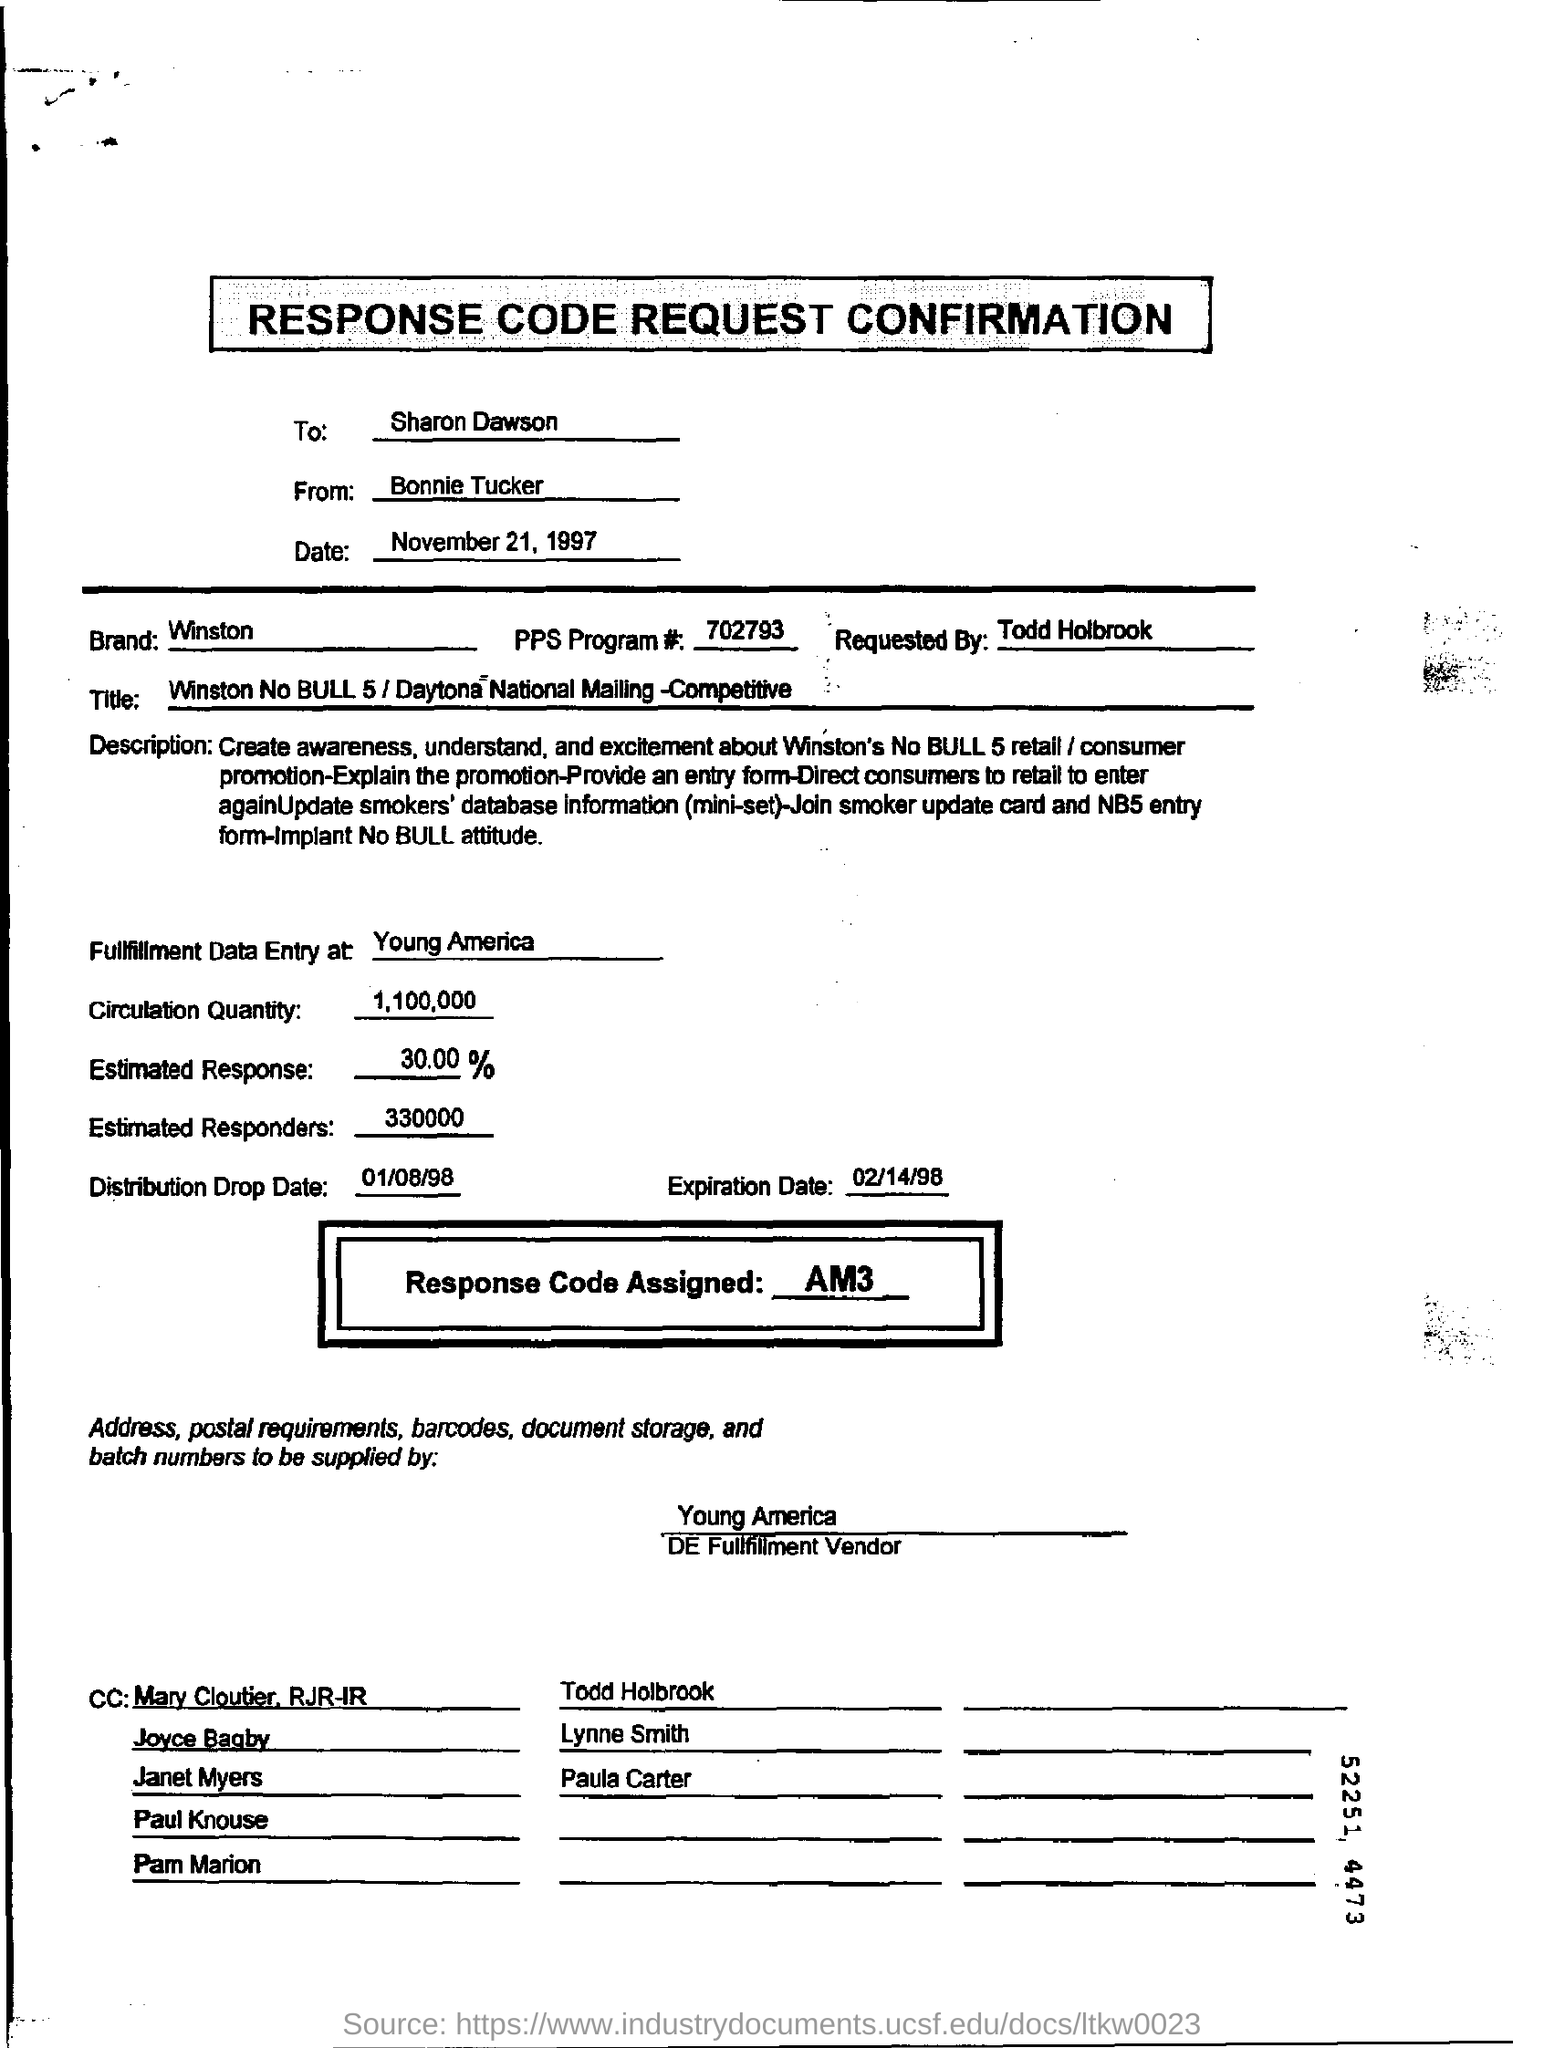Identify some key points in this picture. The individual who requested the response code request confirmation form is Todd Holbrook. The number of estimated responders mentioned in the form is 330,000. The brand mentioned on the response code request form is Winston. The assigned response code mentioned on the form is AM3. The response code request confirmation form dated November 21, 1997, is a document that provides information about a specific date. 